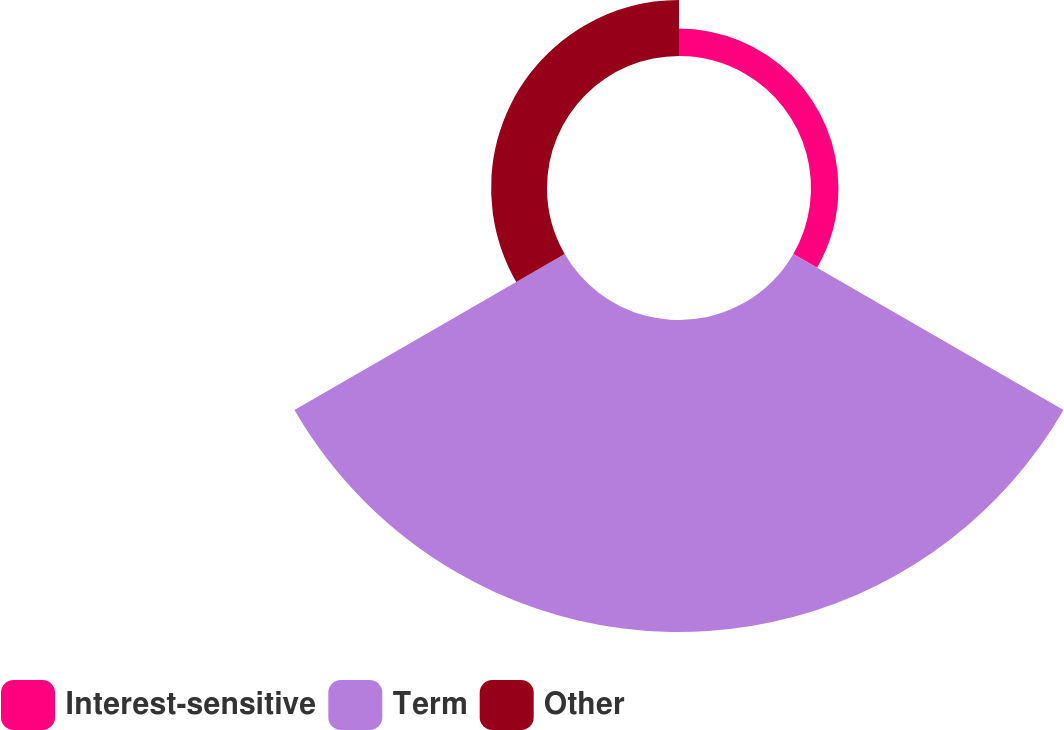Convert chart. <chart><loc_0><loc_0><loc_500><loc_500><pie_chart><fcel>Interest-sensitive<fcel>Term<fcel>Other<nl><fcel>6.94%<fcel>78.92%<fcel>14.14%<nl></chart> 